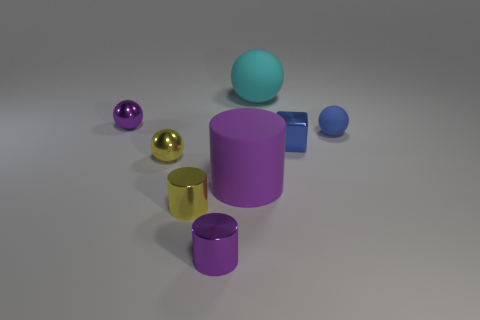Subtract all yellow cylinders. How many cylinders are left? 2 Add 2 small purple balls. How many objects exist? 10 Subtract all cyan spheres. How many spheres are left? 3 Subtract all cylinders. How many objects are left? 5 Subtract all green cylinders. How many purple balls are left? 1 Subtract all large cyan matte cylinders. Subtract all tiny blue things. How many objects are left? 6 Add 4 blue matte things. How many blue matte things are left? 5 Add 2 purple metallic balls. How many purple metallic balls exist? 3 Subtract 1 purple balls. How many objects are left? 7 Subtract 1 cubes. How many cubes are left? 0 